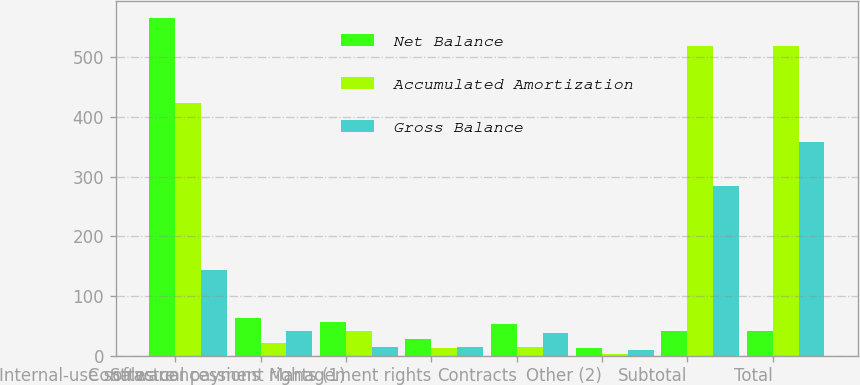Convert chart. <chart><loc_0><loc_0><loc_500><loc_500><stacked_bar_chart><ecel><fcel>Internal-use software<fcel>Sales concessions<fcel>Contractual payment rights (1)<fcel>Management rights<fcel>Contracts<fcel>Other (2)<fcel>Subtotal<fcel>Total<nl><fcel>Net Balance<fcel>567<fcel>63<fcel>56<fcel>28<fcel>53<fcel>12<fcel>41.5<fcel>41.5<nl><fcel>Accumulated Amortization<fcel>424<fcel>22<fcel>42<fcel>13<fcel>15<fcel>2<fcel>519<fcel>519<nl><fcel>Gross Balance<fcel>143<fcel>41<fcel>14<fcel>15<fcel>38<fcel>10<fcel>285<fcel>359<nl></chart> 